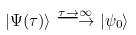<formula> <loc_0><loc_0><loc_500><loc_500>| \Psi ( \tau ) \rangle \stackrel { \tau \rightarrow \infty } { \longrightarrow } | \psi _ { 0 } \rangle</formula> 